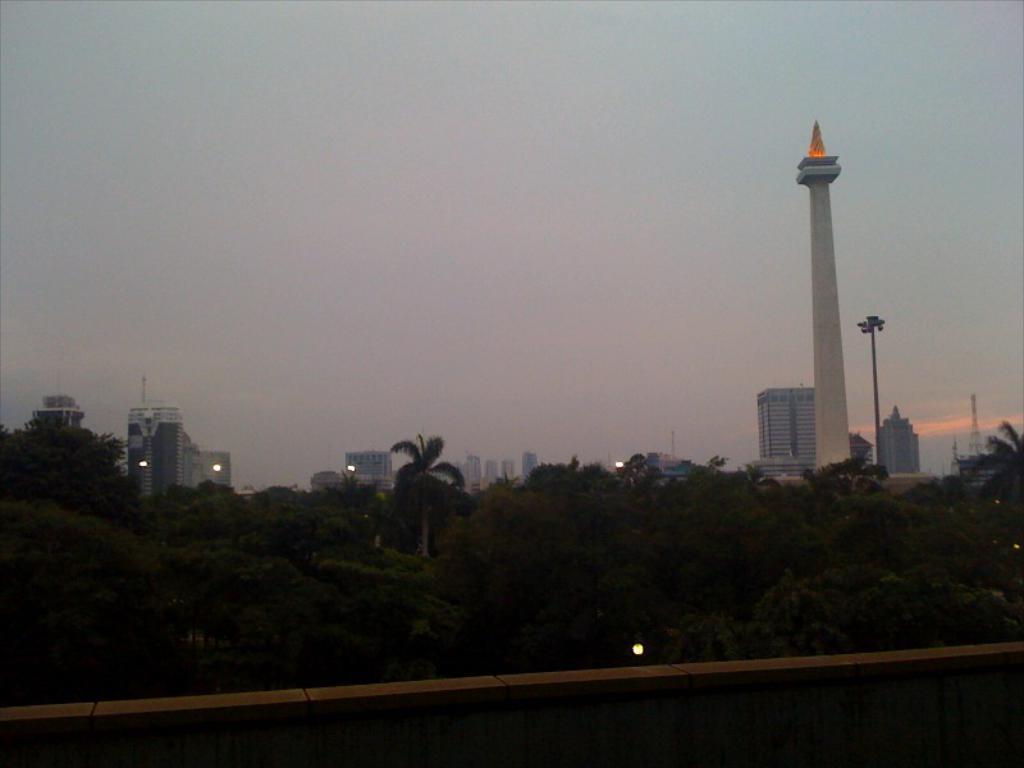Describe this image in one or two sentences. In the picture I can see some trees and few buildings. 